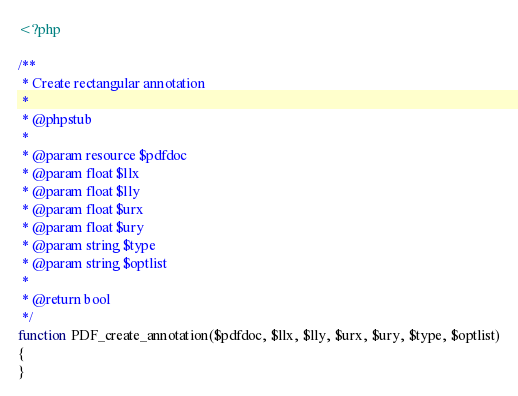<code> <loc_0><loc_0><loc_500><loc_500><_PHP_><?php

/**
 * Create rectangular annotation
 *
 * @phpstub
 *
 * @param resource $pdfdoc
 * @param float $llx
 * @param float $lly
 * @param float $urx
 * @param float $ury
 * @param string $type
 * @param string $optlist
 *
 * @return bool
 */
function PDF_create_annotation($pdfdoc, $llx, $lly, $urx, $ury, $type, $optlist)
{
}</code> 